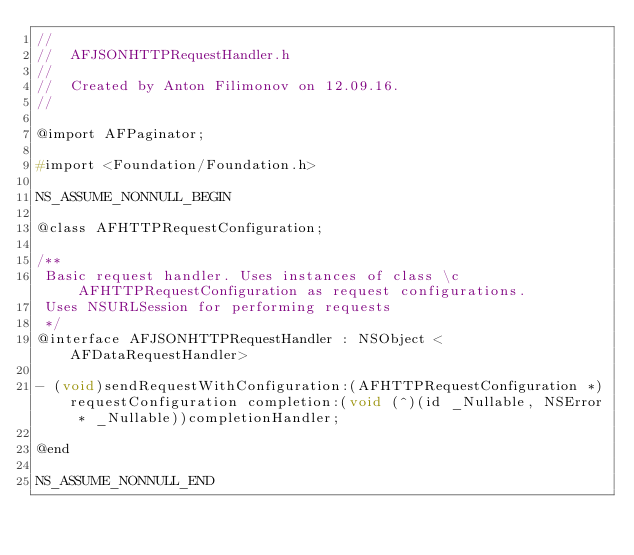<code> <loc_0><loc_0><loc_500><loc_500><_C_>//
//  AFJSONHTTPRequestHandler.h
//
//  Created by Anton Filimonov on 12.09.16.
//

@import AFPaginator;

#import <Foundation/Foundation.h>

NS_ASSUME_NONNULL_BEGIN

@class AFHTTPRequestConfiguration;

/**
 Basic request handler. Uses instances of class \c AFHTTPRequestConfiguration as request configurations. 
 Uses NSURLSession for performing requests
 */
@interface AFJSONHTTPRequestHandler : NSObject <AFDataRequestHandler>

- (void)sendRequestWithConfiguration:(AFHTTPRequestConfiguration *)requestConfiguration completion:(void (^)(id _Nullable, NSError * _Nullable))completionHandler;

@end

NS_ASSUME_NONNULL_END
</code> 